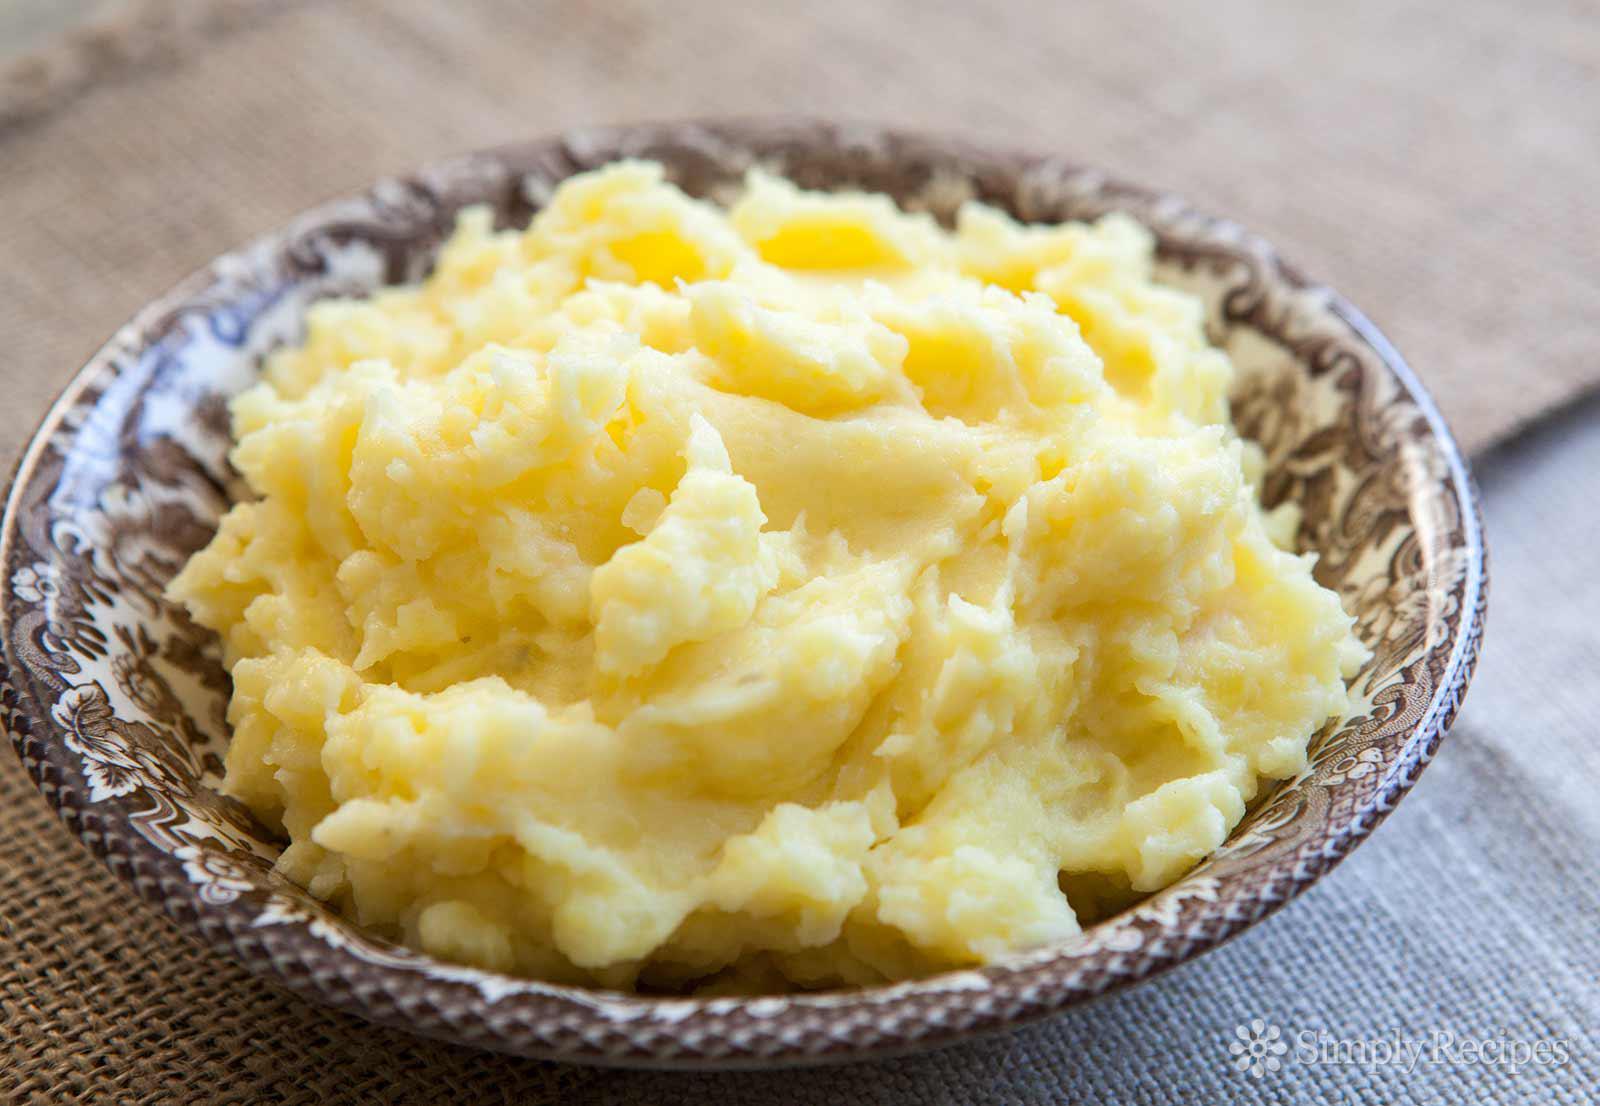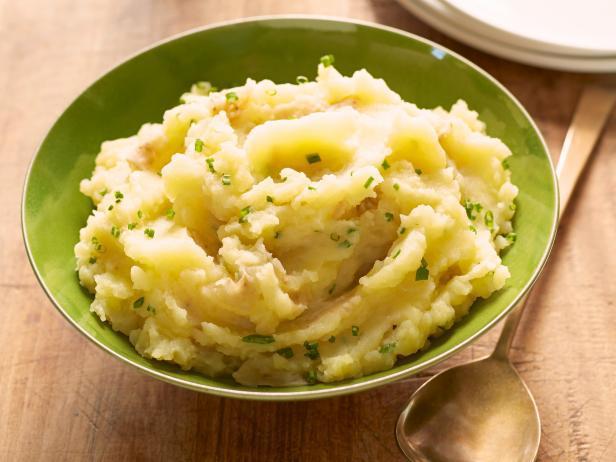The first image is the image on the left, the second image is the image on the right. For the images displayed, is the sentence "One image shows mashed potatoes with chives served in a square white bowl." factually correct? Answer yes or no. No. 